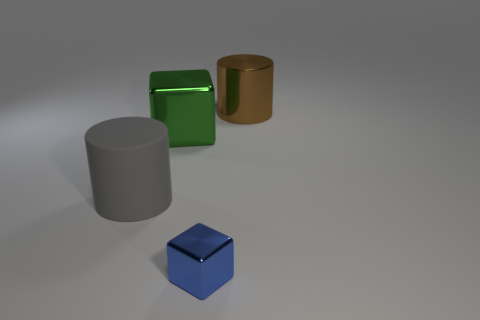Are there any other things that are made of the same material as the large gray thing?
Your response must be concise. No. Are there any other things that are the same size as the blue thing?
Keep it short and to the point. No. Are there fewer big metal cylinders that are left of the tiny blue object than large cylinders?
Provide a succinct answer. Yes. How many other things are there of the same material as the green object?
Keep it short and to the point. 2. Does the blue metal cube have the same size as the gray cylinder?
Your answer should be very brief. No. What number of objects are either cylinders that are right of the tiny blue shiny block or brown shiny things?
Offer a very short reply. 1. What is the material of the large cylinder on the left side of the big cylinder that is behind the gray thing?
Provide a short and direct response. Rubber. Are there any large objects of the same shape as the tiny object?
Your answer should be very brief. Yes. There is a rubber cylinder; is its size the same as the cube behind the large rubber thing?
Provide a succinct answer. Yes. What number of objects are cylinders right of the small blue metallic thing or objects on the right side of the tiny shiny block?
Make the answer very short. 1. 